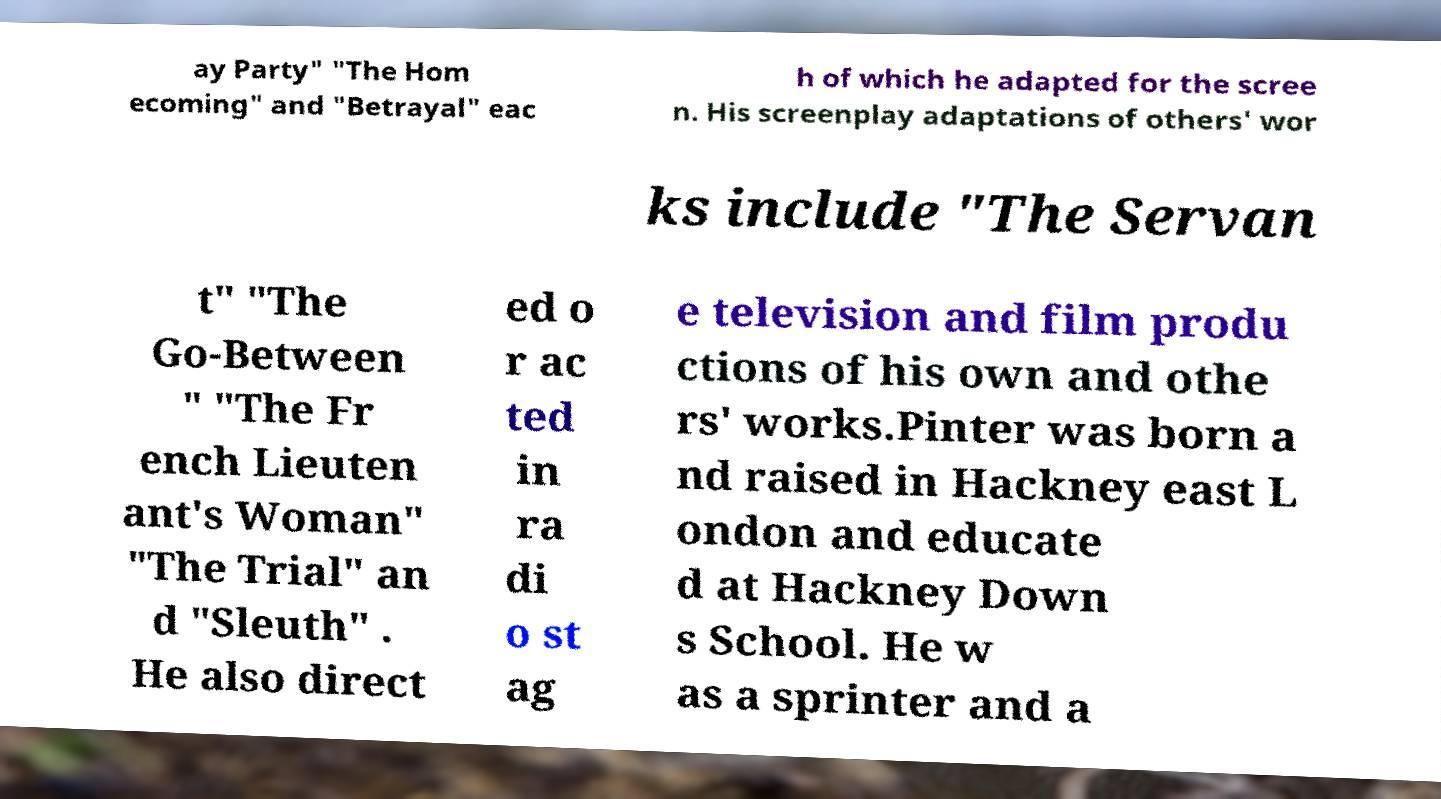Please identify and transcribe the text found in this image. ay Party" "The Hom ecoming" and "Betrayal" eac h of which he adapted for the scree n. His screenplay adaptations of others' wor ks include "The Servan t" "The Go-Between " "The Fr ench Lieuten ant's Woman" "The Trial" an d "Sleuth" . He also direct ed o r ac ted in ra di o st ag e television and film produ ctions of his own and othe rs' works.Pinter was born a nd raised in Hackney east L ondon and educate d at Hackney Down s School. He w as a sprinter and a 